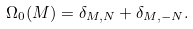Convert formula to latex. <formula><loc_0><loc_0><loc_500><loc_500>\Omega _ { 0 } ( M ) = \delta _ { M , N } + \delta _ { M , - N } .</formula> 